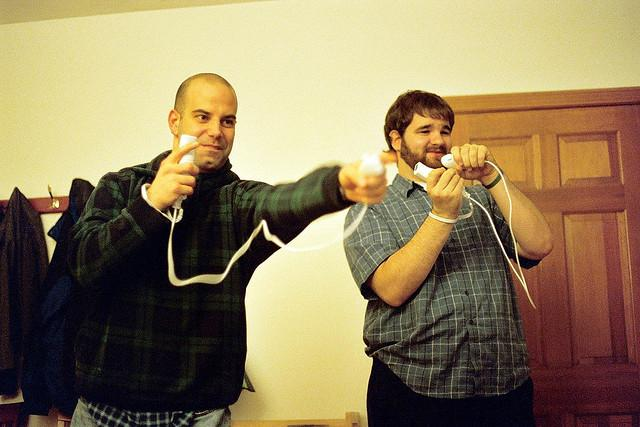What activity is the individual engaging in? playing wii 